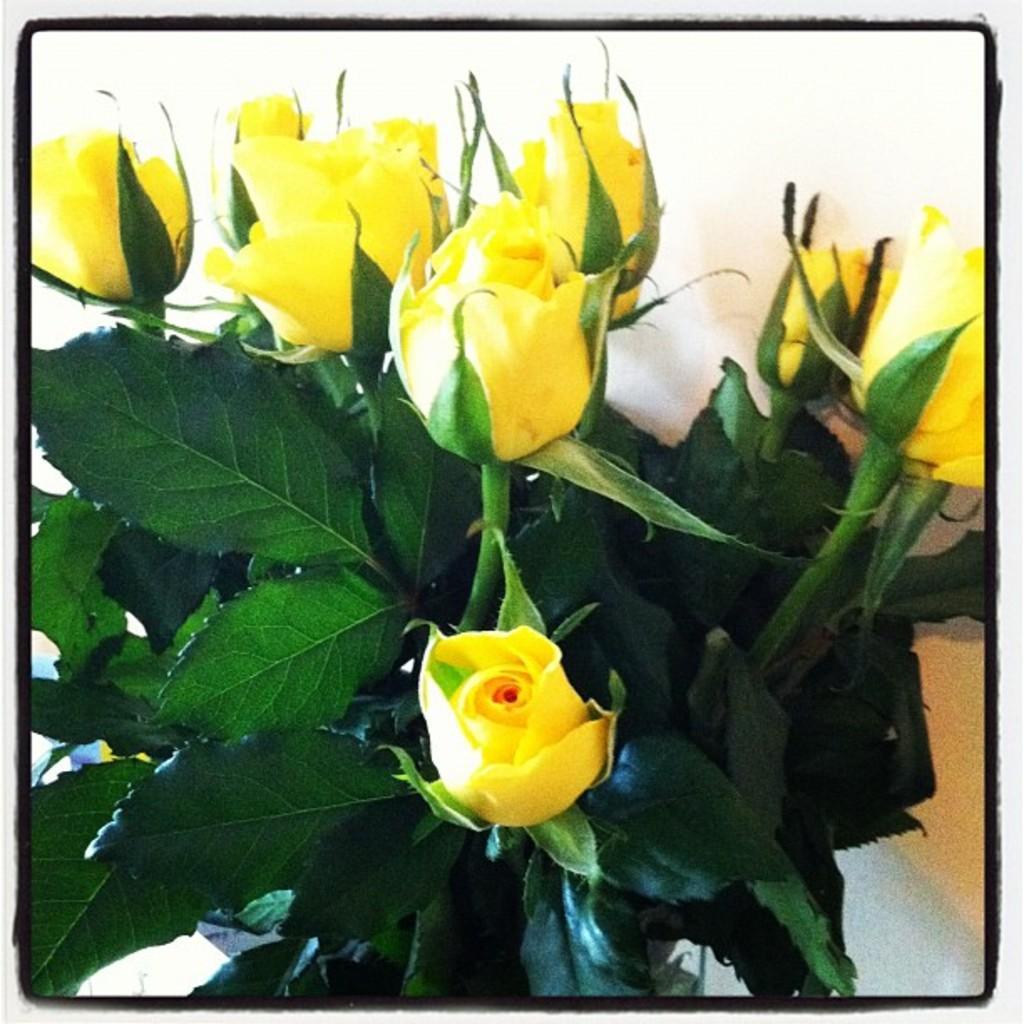Can you describe this image briefly? In this image we can see yellow color rose flowers with green color leaves. 